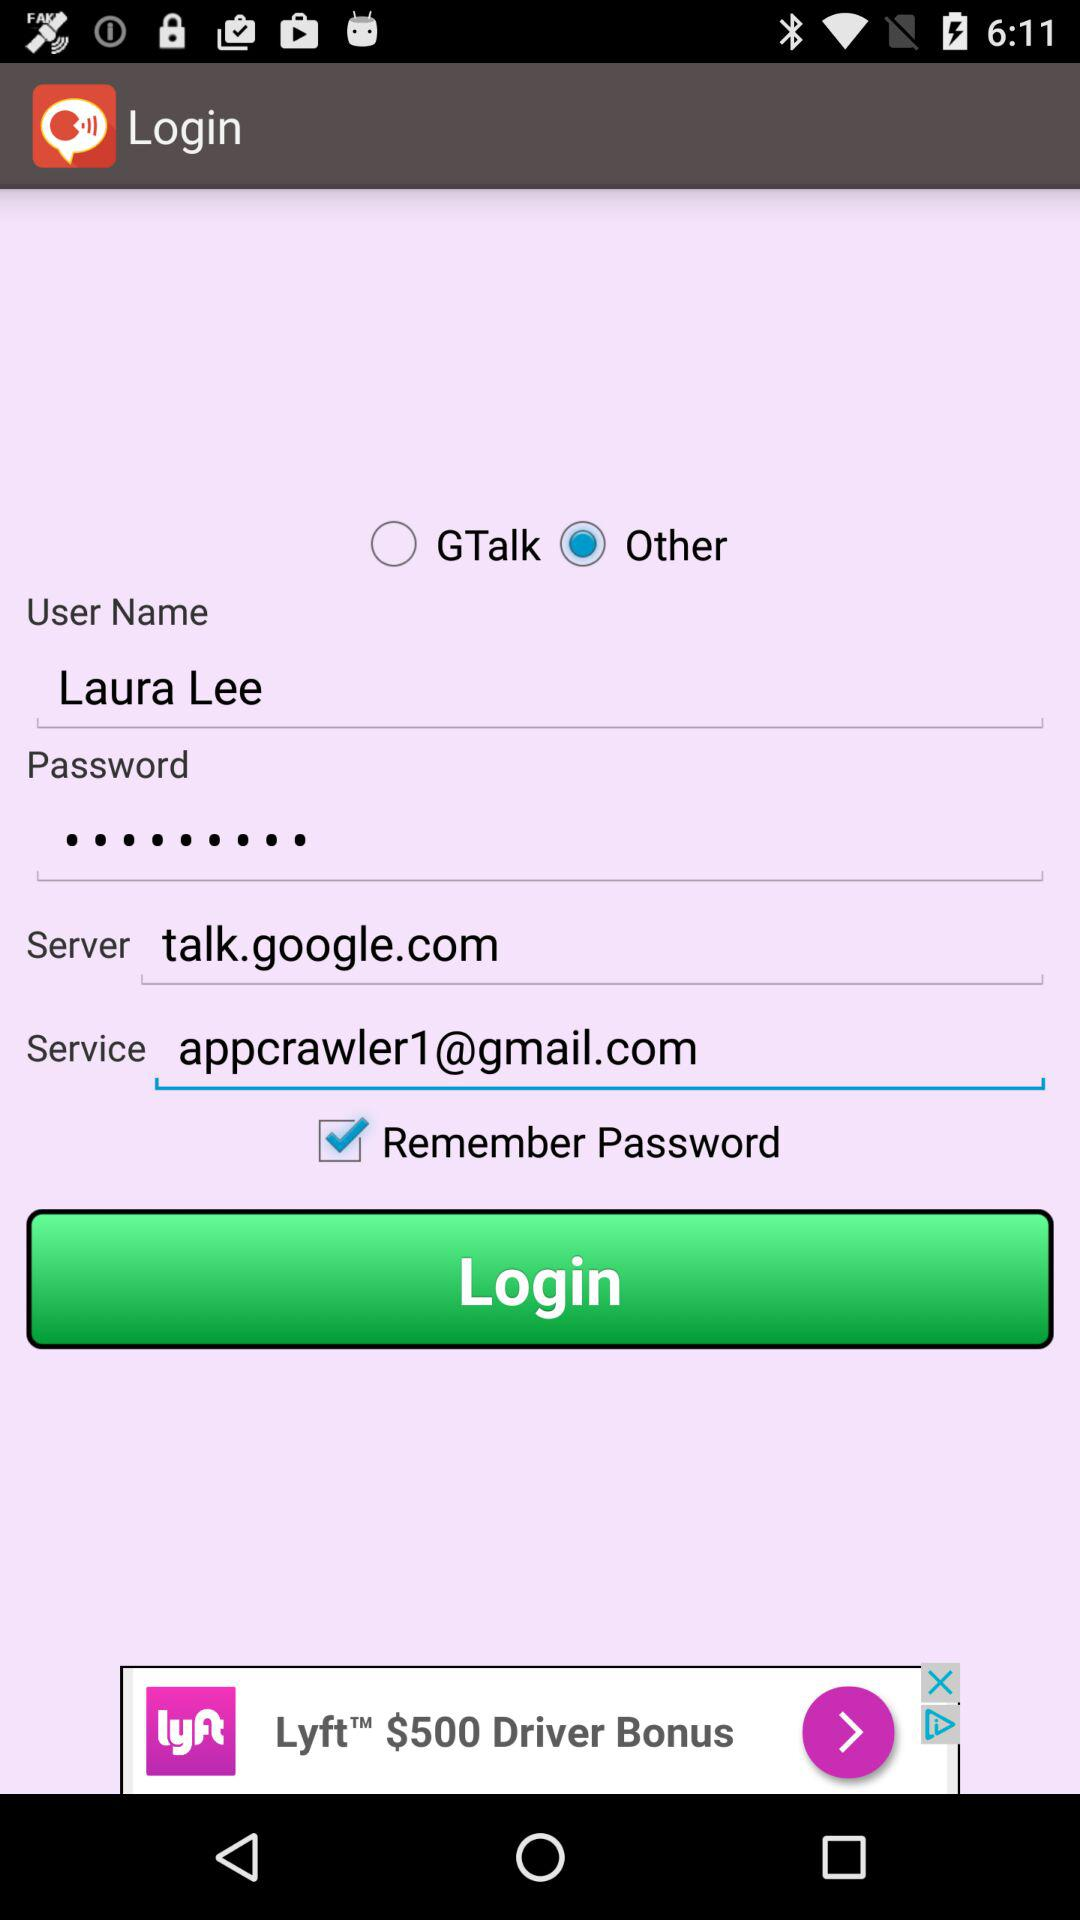Which option is selected? The selected option is "Other". 